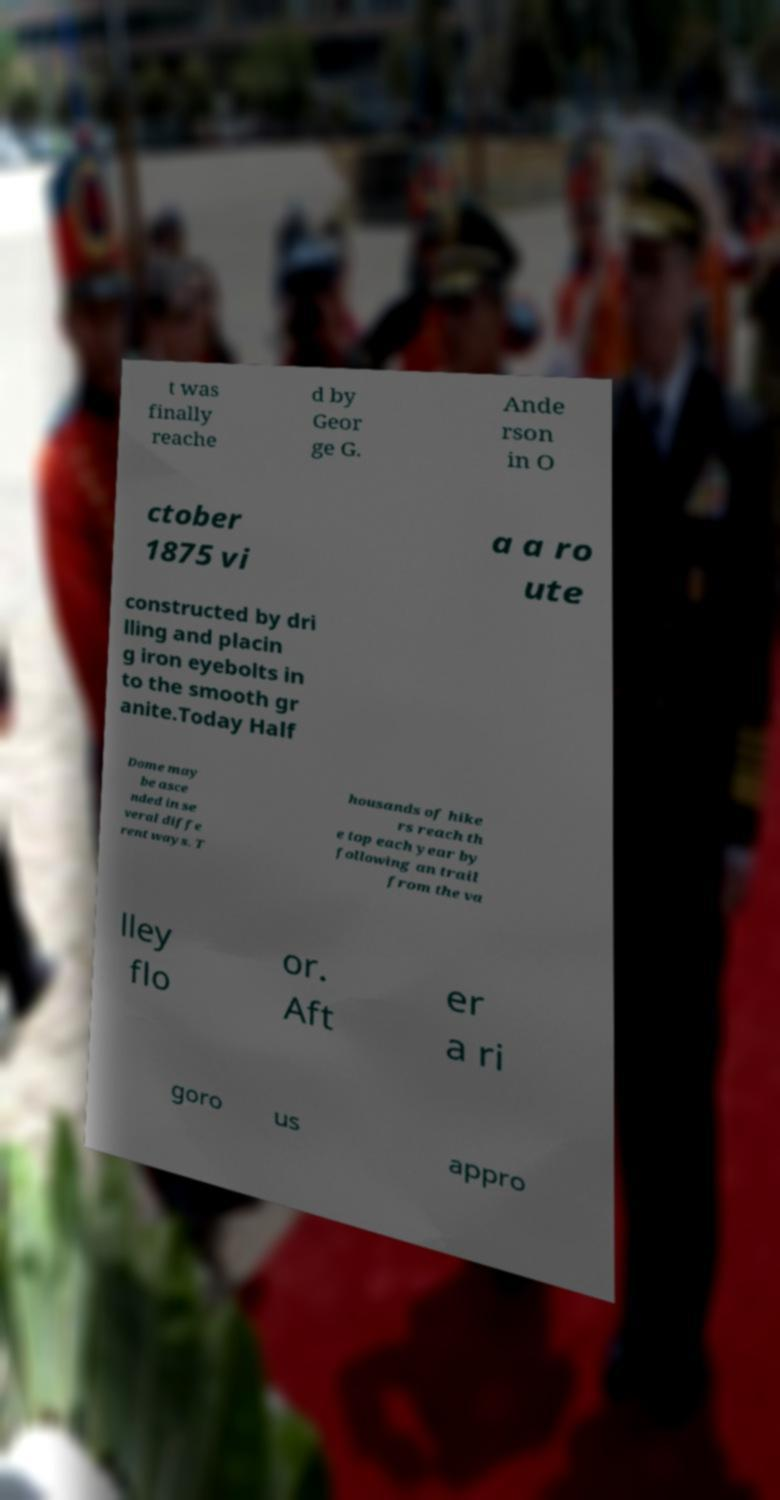Can you read and provide the text displayed in the image?This photo seems to have some interesting text. Can you extract and type it out for me? t was finally reache d by Geor ge G. Ande rson in O ctober 1875 vi a a ro ute constructed by dri lling and placin g iron eyebolts in to the smooth gr anite.Today Half Dome may be asce nded in se veral diffe rent ways. T housands of hike rs reach th e top each year by following an trail from the va lley flo or. Aft er a ri goro us appro 